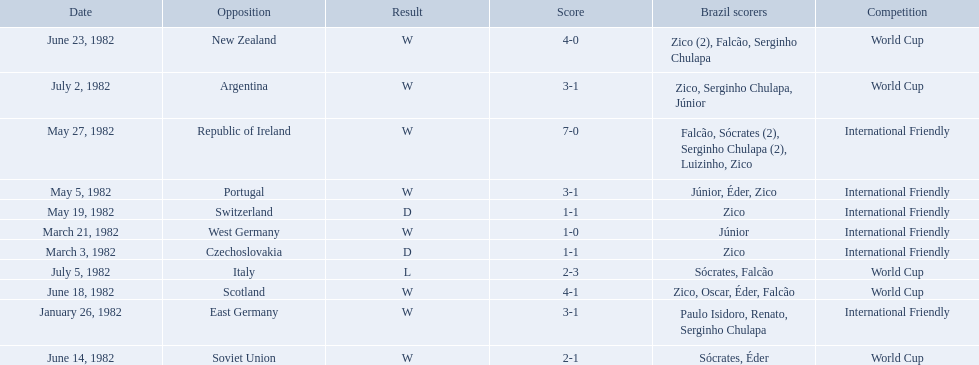What were the scores of each of game in the 1982 brazilian football games? 3-1, 1-1, 1-0, 3-1, 1-1, 7-0, 2-1, 4-1, 4-0, 3-1, 2-3. Of those, which were scores from games against portugal and the soviet union? 3-1, 2-1. And between those two games, against which country did brazil score more goals? Portugal. How many goals did brazil score against the soviet union? 2-1. How many goals did brazil score against portugal? 3-1. Did brazil score more goals against portugal or the soviet union? Portugal. 